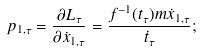<formula> <loc_0><loc_0><loc_500><loc_500>p _ { 1 , \tau } = \frac { \partial L _ { \tau } } { \partial \dot { x } _ { 1 , \tau } } = \frac { f ^ { - 1 } ( t _ { \tau } ) m \dot { x } _ { 1 , \tau } } { \dot { t } _ { \tau } } ;</formula> 